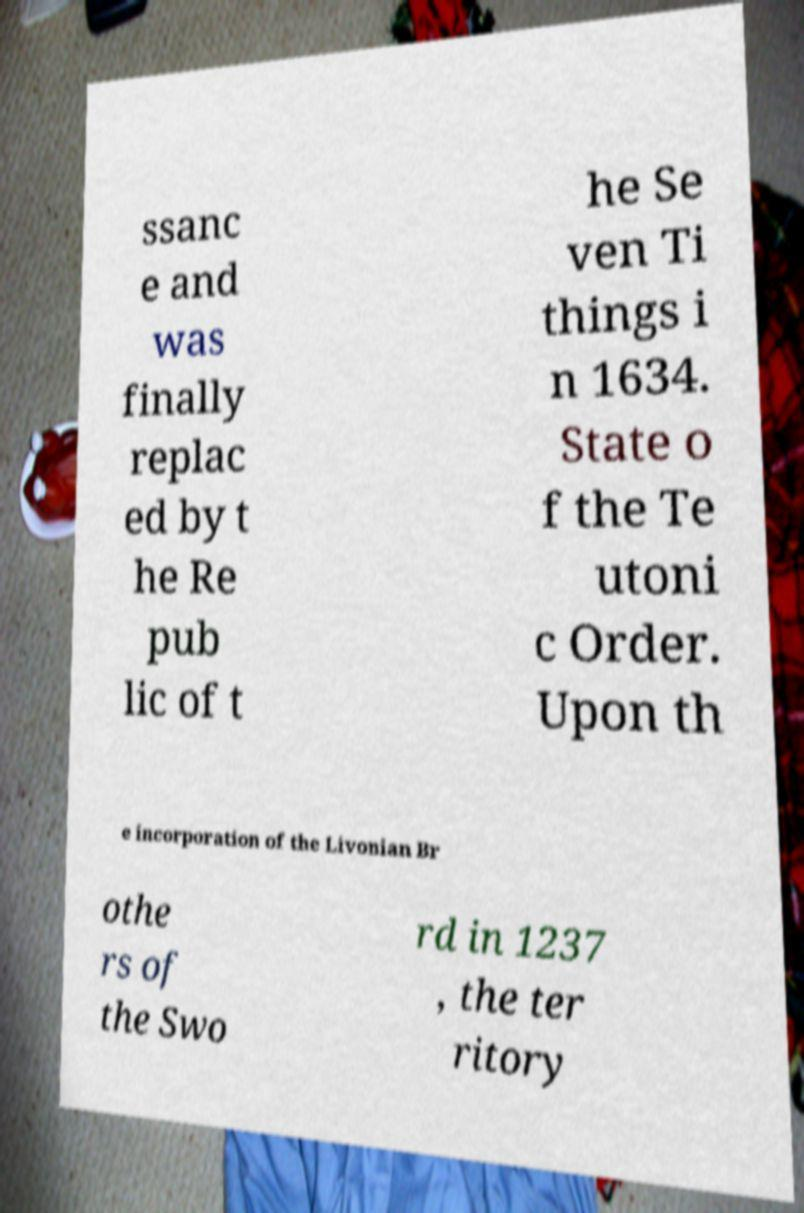Could you assist in decoding the text presented in this image and type it out clearly? ssanc e and was finally replac ed by t he Re pub lic of t he Se ven Ti things i n 1634. State o f the Te utoni c Order. Upon th e incorporation of the Livonian Br othe rs of the Swo rd in 1237 , the ter ritory 